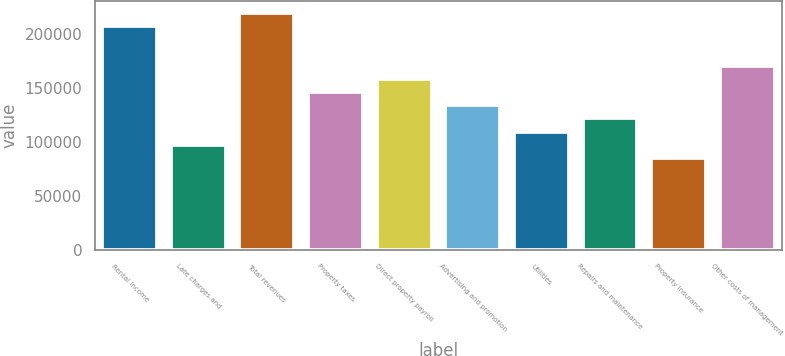Convert chart to OTSL. <chart><loc_0><loc_0><loc_500><loc_500><bar_chart><fcel>Rental income<fcel>Late charges and<fcel>Total revenues<fcel>Property taxes<fcel>Direct property payroll<fcel>Advertising and promotion<fcel>Utilities<fcel>Repairs and maintenance<fcel>Property insurance<fcel>Other costs of management<nl><fcel>207481<fcel>97638.7<fcel>219685<fcel>146457<fcel>158662<fcel>134253<fcel>109843<fcel>122048<fcel>85434<fcel>170867<nl></chart> 